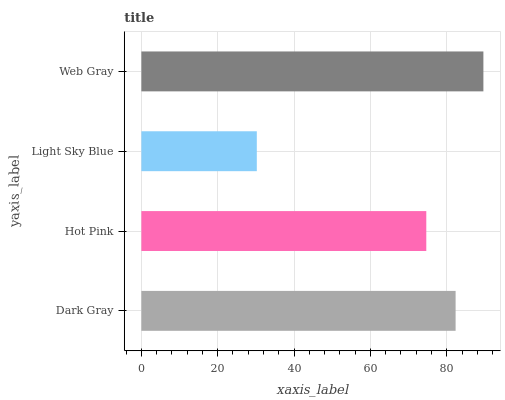Is Light Sky Blue the minimum?
Answer yes or no. Yes. Is Web Gray the maximum?
Answer yes or no. Yes. Is Hot Pink the minimum?
Answer yes or no. No. Is Hot Pink the maximum?
Answer yes or no. No. Is Dark Gray greater than Hot Pink?
Answer yes or no. Yes. Is Hot Pink less than Dark Gray?
Answer yes or no. Yes. Is Hot Pink greater than Dark Gray?
Answer yes or no. No. Is Dark Gray less than Hot Pink?
Answer yes or no. No. Is Dark Gray the high median?
Answer yes or no. Yes. Is Hot Pink the low median?
Answer yes or no. Yes. Is Web Gray the high median?
Answer yes or no. No. Is Web Gray the low median?
Answer yes or no. No. 